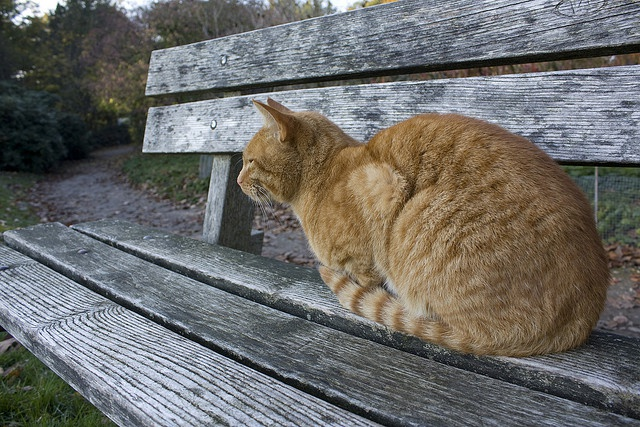Describe the objects in this image and their specific colors. I can see bench in gray, black, and darkgray tones and cat in black, maroon, gray, and tan tones in this image. 